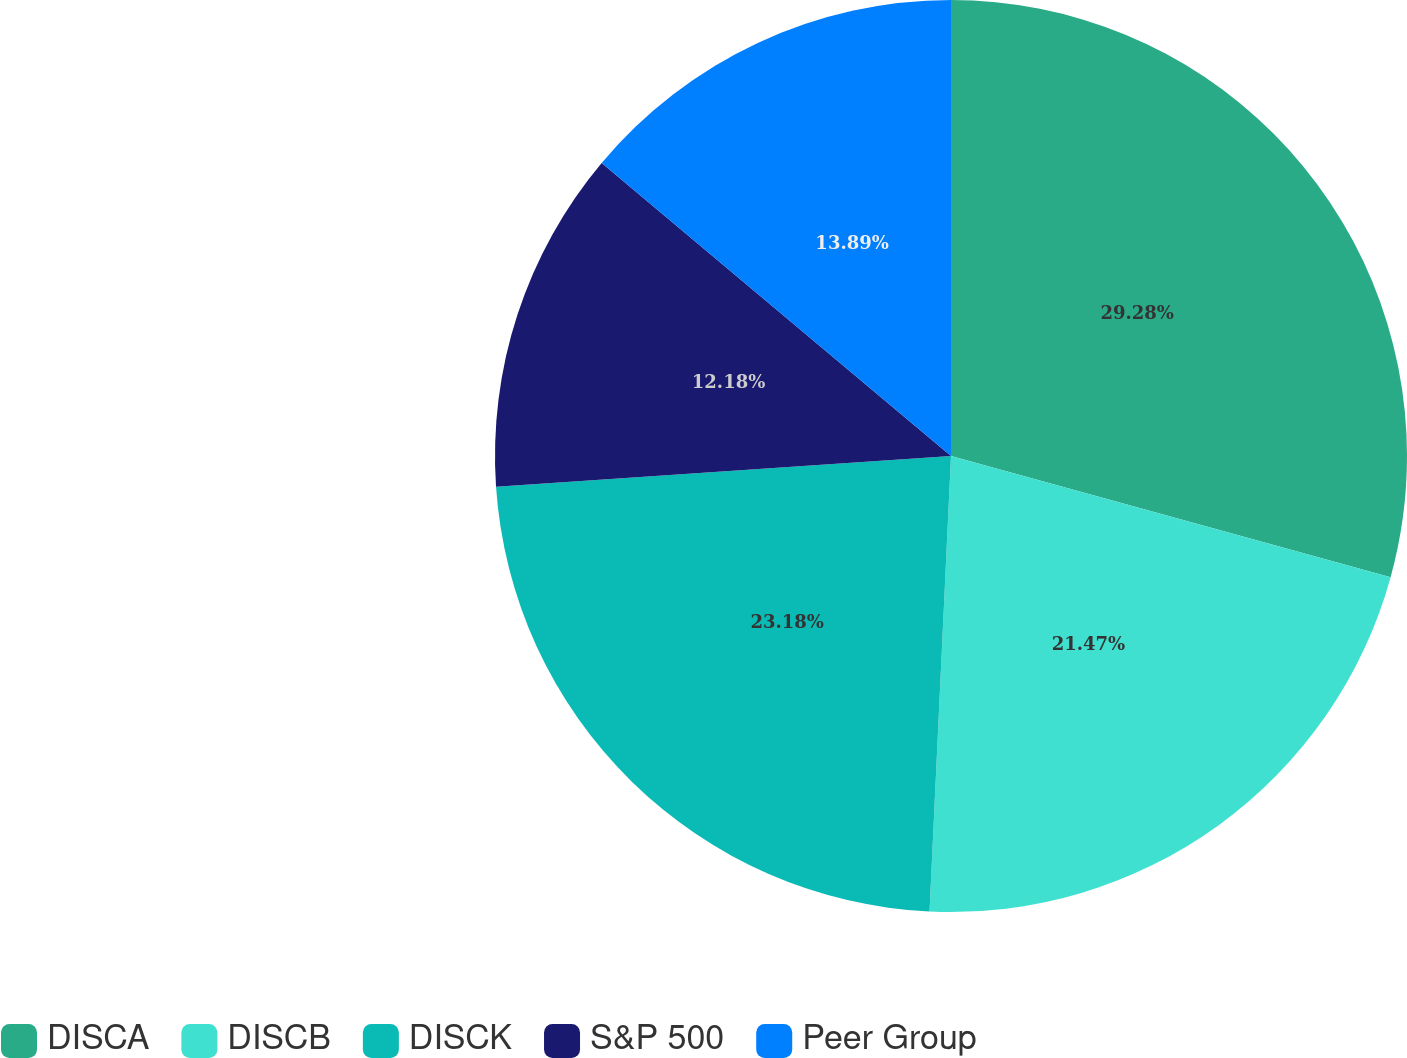Convert chart. <chart><loc_0><loc_0><loc_500><loc_500><pie_chart><fcel>DISCA<fcel>DISCB<fcel>DISCK<fcel>S&P 500<fcel>Peer Group<nl><fcel>29.28%<fcel>21.47%<fcel>23.18%<fcel>12.18%<fcel>13.89%<nl></chart> 